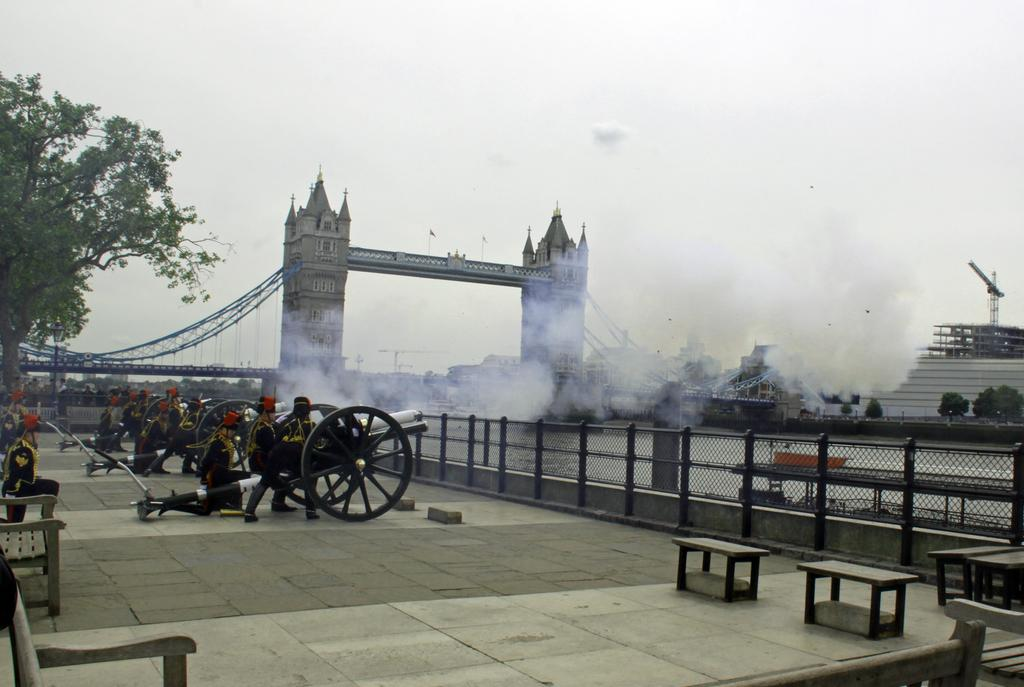Who is present on the left side of the image? There are people on the left side of the image. What are the people doing in the image? The people are using cannons. What structure is located in the middle of the image? There is a London bridge in the middle of the image. What can be seen on the right side of the image? There is a ship on the right side of the image. What is visible at the top of the image? The sky is visible at the top of the image. What river is the ship embarking on a voyage in the image? There is no river present in the image, and the ship's voyage cannot be determined from the information provided. 